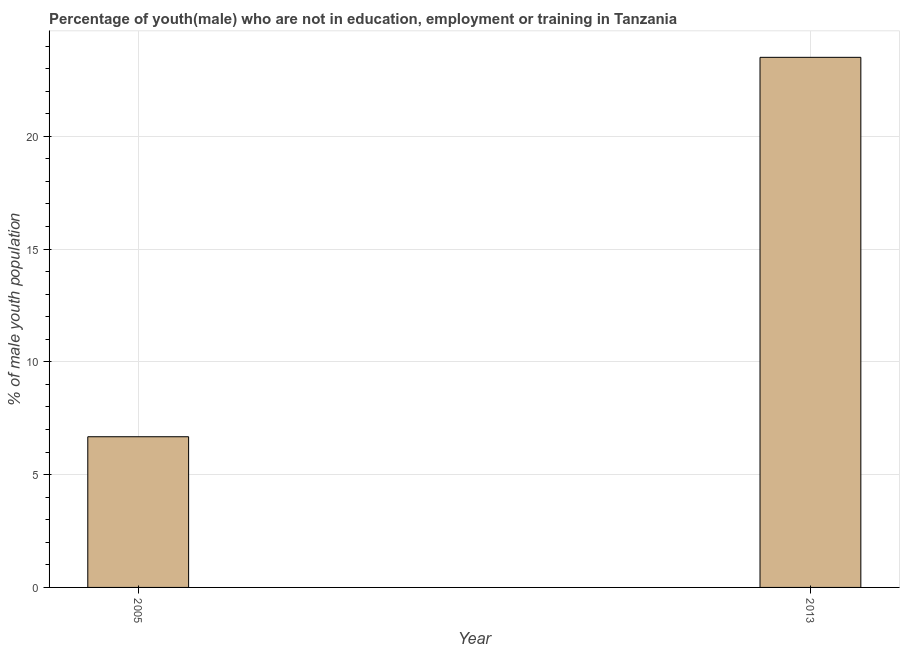What is the title of the graph?
Your answer should be compact. Percentage of youth(male) who are not in education, employment or training in Tanzania. What is the label or title of the X-axis?
Ensure brevity in your answer.  Year. What is the label or title of the Y-axis?
Offer a very short reply. % of male youth population. Across all years, what is the minimum unemployed male youth population?
Give a very brief answer. 6.68. In which year was the unemployed male youth population maximum?
Your response must be concise. 2013. What is the sum of the unemployed male youth population?
Ensure brevity in your answer.  30.18. What is the difference between the unemployed male youth population in 2005 and 2013?
Your response must be concise. -16.82. What is the average unemployed male youth population per year?
Your answer should be compact. 15.09. What is the median unemployed male youth population?
Your response must be concise. 15.09. In how many years, is the unemployed male youth population greater than 16 %?
Make the answer very short. 1. Do a majority of the years between 2013 and 2005 (inclusive) have unemployed male youth population greater than 13 %?
Your answer should be very brief. No. What is the ratio of the unemployed male youth population in 2005 to that in 2013?
Keep it short and to the point. 0.28. How many bars are there?
Give a very brief answer. 2. How many years are there in the graph?
Your response must be concise. 2. What is the difference between two consecutive major ticks on the Y-axis?
Offer a terse response. 5. What is the % of male youth population of 2005?
Offer a terse response. 6.68. What is the % of male youth population in 2013?
Your answer should be very brief. 23.5. What is the difference between the % of male youth population in 2005 and 2013?
Ensure brevity in your answer.  -16.82. What is the ratio of the % of male youth population in 2005 to that in 2013?
Your answer should be very brief. 0.28. 